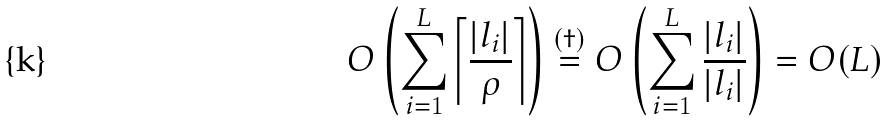<formula> <loc_0><loc_0><loc_500><loc_500>O \left ( \sum _ { i = 1 } ^ { L } \left \lceil \frac { | l _ { i } | } { \rho } \right \rceil \right ) \stackrel { ( \dag ) } = O \left ( \sum _ { i = 1 } ^ { L } \frac { | l _ { i } | } { | l _ { i } | } \right ) = O ( L )</formula> 